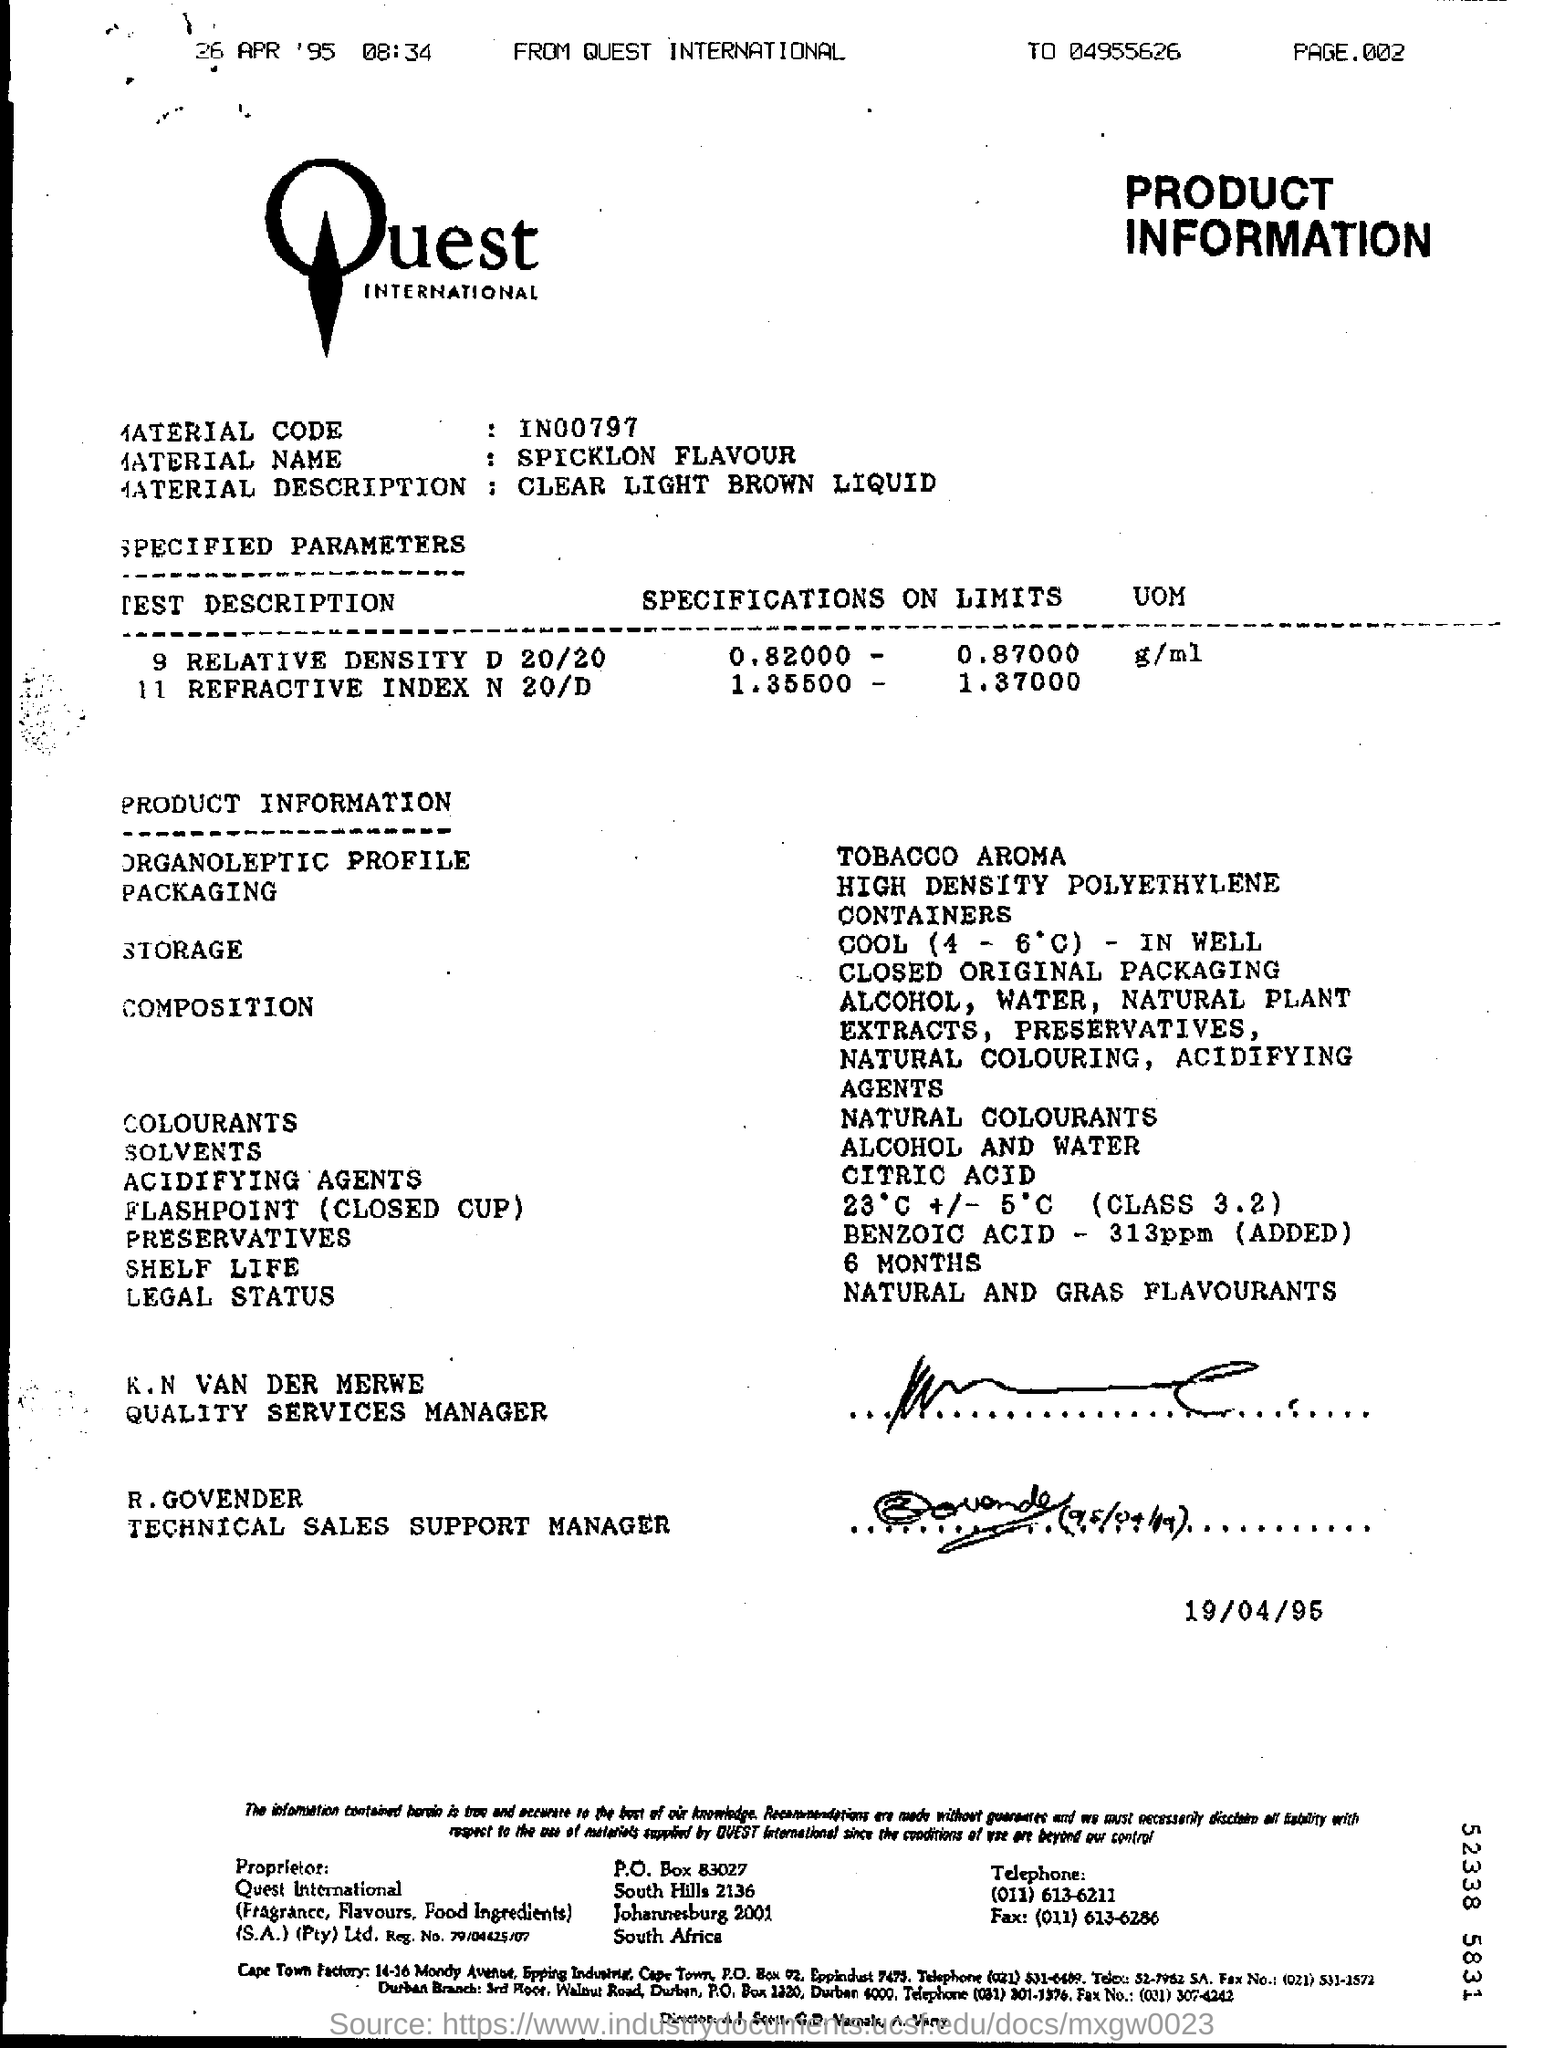Which Company's Product Information is given here?
Make the answer very short. Quest INTERNATIONAL. What is the material name given in the document?
Give a very brief answer. Spicklon flavour. What is the material description mentioned in the document?
Provide a succinct answer. Clear light brown liquid. Who is R. GOVENDER?
Provide a short and direct response. TECHNICAL SALES SUPPORT MANAGER. What are solvents mentioned in the product information?
Keep it short and to the point. Alcohol and water. What is the shelf life of the product?
Offer a terse response. 6 MONTHS. Which colourants are used by the product?
Keep it short and to the point. NATURAL COLOURANTS. Which acidifying agents are used by the product?
Give a very brief answer. Citric acid. 